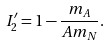Convert formula to latex. <formula><loc_0><loc_0><loc_500><loc_500>I ^ { \prime } _ { 2 } = 1 - \frac { m _ { A } } { A m _ { N } } .</formula> 